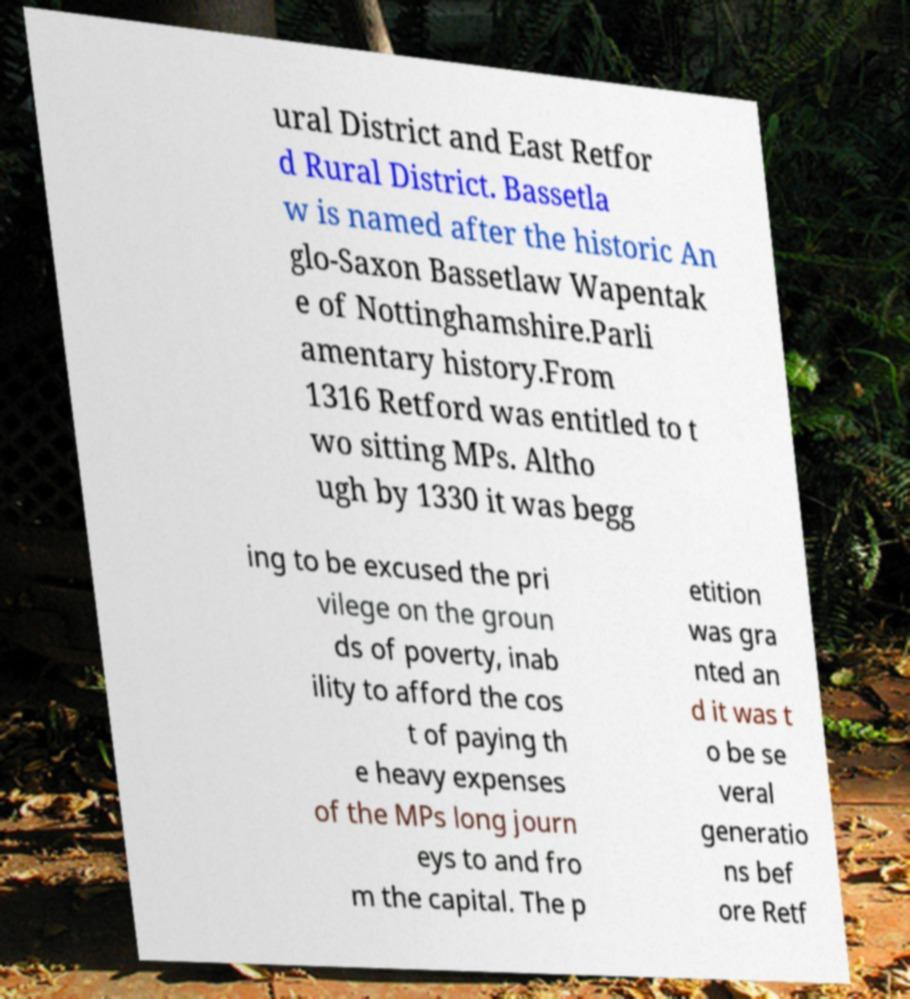Could you extract and type out the text from this image? ural District and East Retfor d Rural District. Bassetla w is named after the historic An glo-Saxon Bassetlaw Wapentak e of Nottinghamshire.Parli amentary history.From 1316 Retford was entitled to t wo sitting MPs. Altho ugh by 1330 it was begg ing to be excused the pri vilege on the groun ds of poverty, inab ility to afford the cos t of paying th e heavy expenses of the MPs long journ eys to and fro m the capital. The p etition was gra nted an d it was t o be se veral generatio ns bef ore Retf 